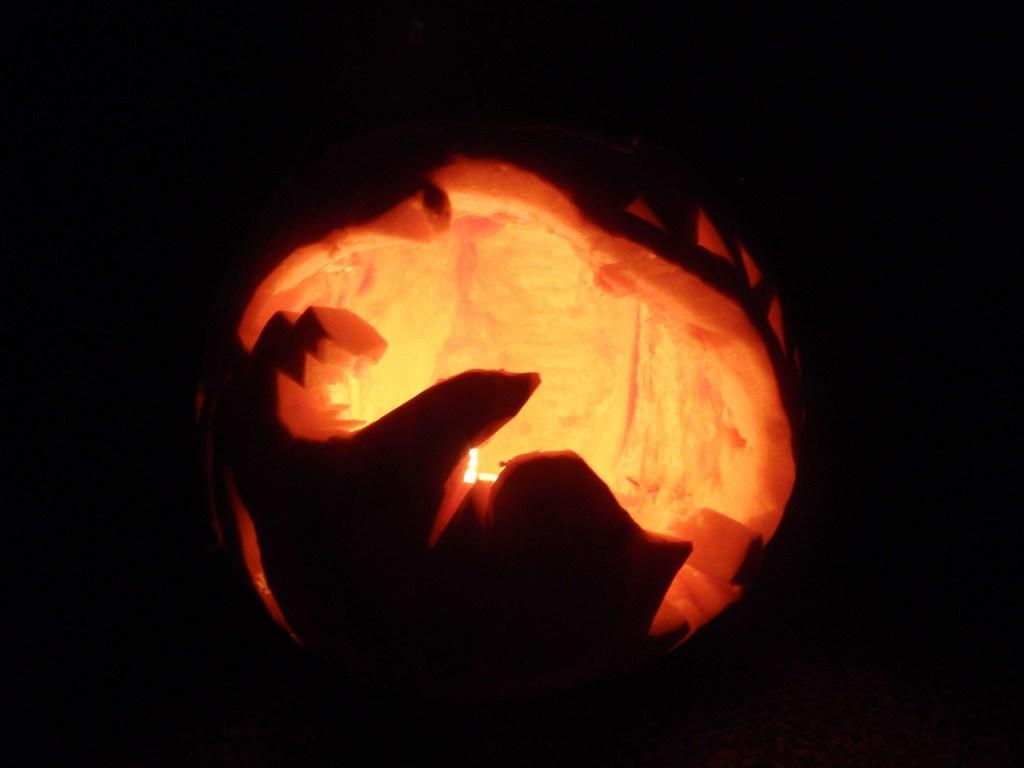What is the main subject of the image? There is a carved pumpkin in the image. What color is the background of the image? The background of the image is black. Can you describe the lighting conditions in the image? The image might have been taken in the dark, as indicated by the black background. What type of engine can be seen powering the spot in the image? There is no engine or spot present in the image; it features a carved pumpkin with a black background. 